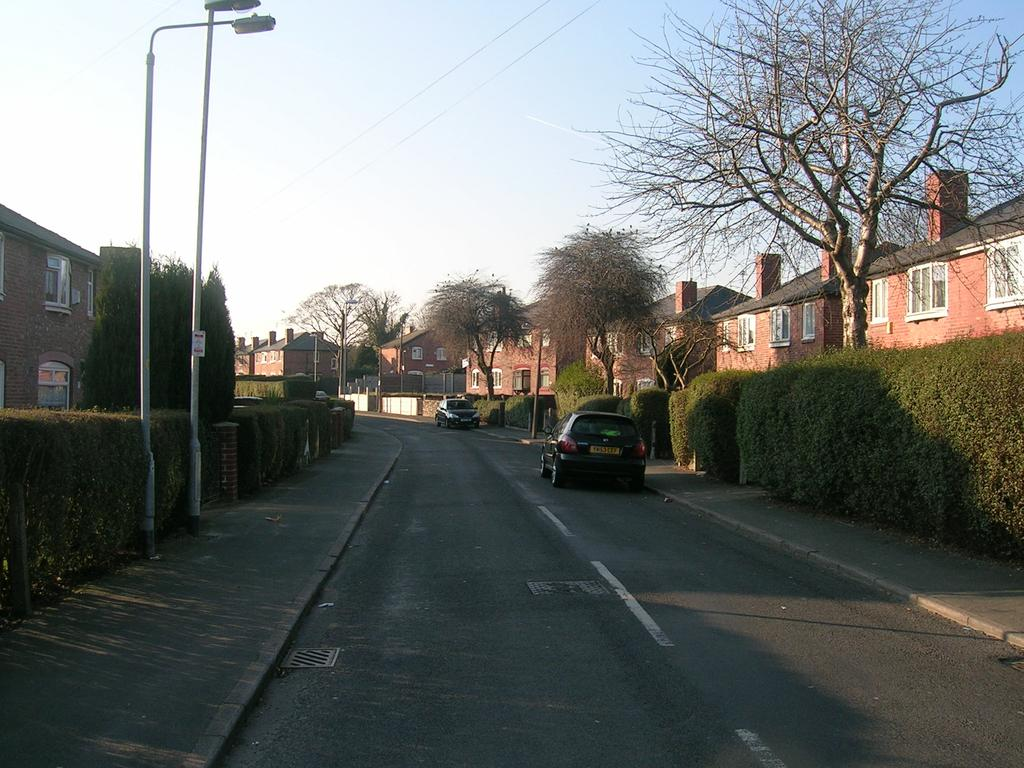What is happening on the road in the image? There are vehicles on the road in the image. What type of vegetation is present beside the vehicles? Shrubs are present beside the vehicles. What else can be seen in the image besides the vehicles and shrubs? Trees, poles, lights, and buildings are visible in the image. How many deer are visible in the image? There are no deer present in the image. What type of health services are available in the image? The image does not depict any health services or facilities. 